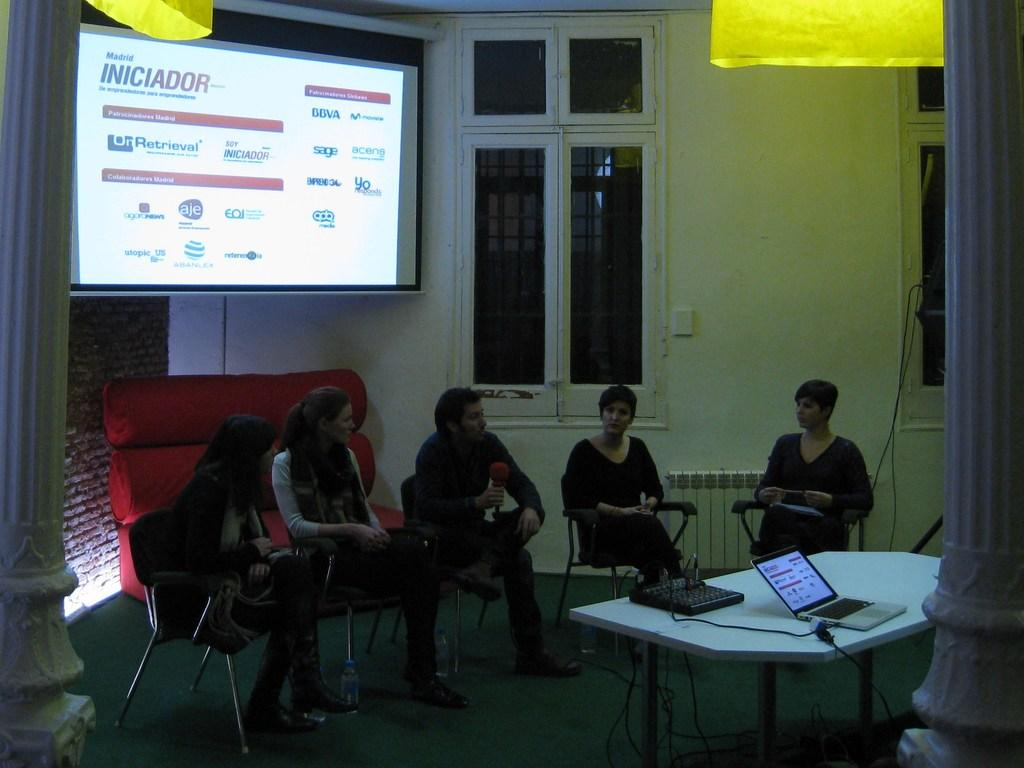What are the people in the image doing? The people in the image are sitting on chairs. What is the main piece of furniture in the image? There is a table in the image. What electronic device is on the table? A laptop is present on the table. What can be seen on the wall or background of the image? There is a projector's screen in the background of the image. What type of pancake is being served on the table in the image? There is no pancake present on the table in the image; instead, there is a laptop. 